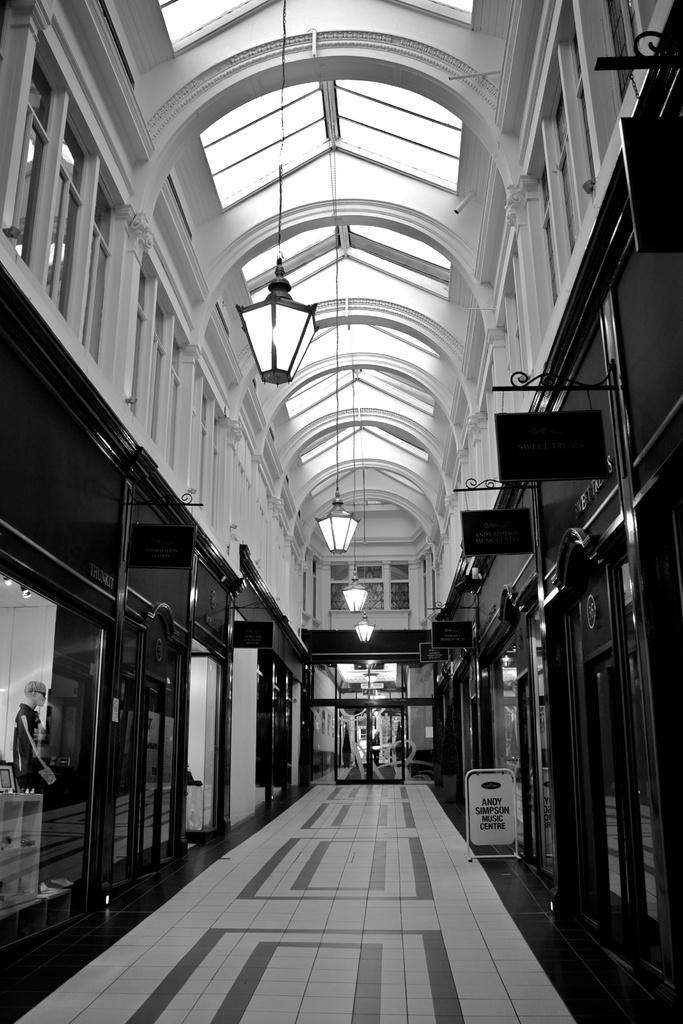Please provide a concise description of this image. This is a black and white image I can see glass doors on the left, right and in the center of the image. At the top of the image I can see rooftop with some lamps. On the left side of the image I can see a shop in which I can see a mannequin. 